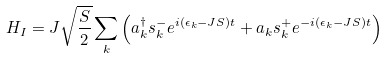<formula> <loc_0><loc_0><loc_500><loc_500>H _ { I } = J \sqrt { \frac { S } { 2 } } \sum _ { k } \left ( a ^ { \dagger } _ { k } s ^ { - } _ { k } e ^ { i ( \epsilon _ { k } - J S ) t } + a _ { k } s ^ { + } _ { k } e ^ { - i ( \epsilon _ { k } - J S ) t } \right )</formula> 